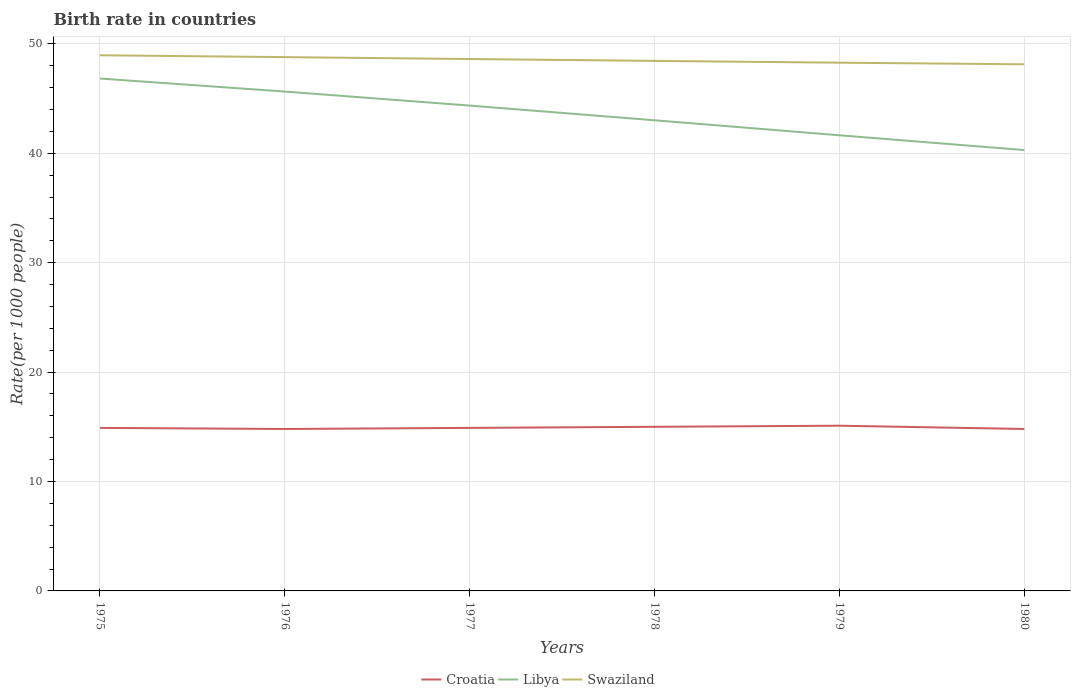How many different coloured lines are there?
Make the answer very short. 3. Does the line corresponding to Swaziland intersect with the line corresponding to Libya?
Your answer should be compact. No. Across all years, what is the maximum birth rate in Swaziland?
Provide a short and direct response. 48.13. In which year was the birth rate in Swaziland maximum?
Offer a very short reply. 1980. What is the total birth rate in Croatia in the graph?
Offer a very short reply. -0.3. What is the difference between the highest and the second highest birth rate in Croatia?
Your answer should be compact. 0.3. Is the birth rate in Croatia strictly greater than the birth rate in Swaziland over the years?
Keep it short and to the point. Yes. How many years are there in the graph?
Make the answer very short. 6. Are the values on the major ticks of Y-axis written in scientific E-notation?
Make the answer very short. No. Does the graph contain any zero values?
Provide a short and direct response. No. Does the graph contain grids?
Your answer should be compact. Yes. How are the legend labels stacked?
Your response must be concise. Horizontal. What is the title of the graph?
Ensure brevity in your answer.  Birth rate in countries. What is the label or title of the Y-axis?
Make the answer very short. Rate(per 1000 people). What is the Rate(per 1000 people) of Libya in 1975?
Keep it short and to the point. 46.83. What is the Rate(per 1000 people) in Swaziland in 1975?
Offer a terse response. 48.95. What is the Rate(per 1000 people) of Libya in 1976?
Provide a succinct answer. 45.64. What is the Rate(per 1000 people) in Swaziland in 1976?
Offer a terse response. 48.78. What is the Rate(per 1000 people) in Croatia in 1977?
Ensure brevity in your answer.  14.9. What is the Rate(per 1000 people) in Libya in 1977?
Your response must be concise. 44.36. What is the Rate(per 1000 people) in Swaziland in 1977?
Provide a short and direct response. 48.61. What is the Rate(per 1000 people) in Libya in 1978?
Provide a short and direct response. 43.01. What is the Rate(per 1000 people) in Swaziland in 1978?
Give a very brief answer. 48.44. What is the Rate(per 1000 people) in Libya in 1979?
Provide a short and direct response. 41.64. What is the Rate(per 1000 people) in Swaziland in 1979?
Ensure brevity in your answer.  48.28. What is the Rate(per 1000 people) in Libya in 1980?
Offer a terse response. 40.29. What is the Rate(per 1000 people) in Swaziland in 1980?
Ensure brevity in your answer.  48.13. Across all years, what is the maximum Rate(per 1000 people) of Croatia?
Offer a terse response. 15.1. Across all years, what is the maximum Rate(per 1000 people) of Libya?
Provide a short and direct response. 46.83. Across all years, what is the maximum Rate(per 1000 people) in Swaziland?
Make the answer very short. 48.95. Across all years, what is the minimum Rate(per 1000 people) in Libya?
Your response must be concise. 40.29. Across all years, what is the minimum Rate(per 1000 people) in Swaziland?
Your answer should be compact. 48.13. What is the total Rate(per 1000 people) of Croatia in the graph?
Your answer should be compact. 89.5. What is the total Rate(per 1000 people) of Libya in the graph?
Offer a terse response. 261.77. What is the total Rate(per 1000 people) of Swaziland in the graph?
Offer a very short reply. 291.2. What is the difference between the Rate(per 1000 people) of Libya in 1975 and that in 1976?
Your answer should be compact. 1.19. What is the difference between the Rate(per 1000 people) in Swaziland in 1975 and that in 1976?
Provide a succinct answer. 0.17. What is the difference between the Rate(per 1000 people) in Croatia in 1975 and that in 1977?
Your answer should be compact. 0. What is the difference between the Rate(per 1000 people) in Libya in 1975 and that in 1977?
Offer a very short reply. 2.47. What is the difference between the Rate(per 1000 people) of Swaziland in 1975 and that in 1977?
Make the answer very short. 0.34. What is the difference between the Rate(per 1000 people) of Croatia in 1975 and that in 1978?
Give a very brief answer. -0.1. What is the difference between the Rate(per 1000 people) in Libya in 1975 and that in 1978?
Provide a succinct answer. 3.82. What is the difference between the Rate(per 1000 people) of Swaziland in 1975 and that in 1978?
Provide a succinct answer. 0.52. What is the difference between the Rate(per 1000 people) of Croatia in 1975 and that in 1979?
Your response must be concise. -0.2. What is the difference between the Rate(per 1000 people) of Libya in 1975 and that in 1979?
Offer a very short reply. 5.19. What is the difference between the Rate(per 1000 people) of Swaziland in 1975 and that in 1979?
Give a very brief answer. 0.68. What is the difference between the Rate(per 1000 people) of Croatia in 1975 and that in 1980?
Offer a terse response. 0.1. What is the difference between the Rate(per 1000 people) in Libya in 1975 and that in 1980?
Provide a succinct answer. 6.54. What is the difference between the Rate(per 1000 people) in Swaziland in 1975 and that in 1980?
Your answer should be compact. 0.83. What is the difference between the Rate(per 1000 people) in Libya in 1976 and that in 1977?
Offer a terse response. 1.28. What is the difference between the Rate(per 1000 people) of Swaziland in 1976 and that in 1977?
Make the answer very short. 0.17. What is the difference between the Rate(per 1000 people) of Croatia in 1976 and that in 1978?
Your response must be concise. -0.2. What is the difference between the Rate(per 1000 people) of Libya in 1976 and that in 1978?
Your answer should be very brief. 2.62. What is the difference between the Rate(per 1000 people) of Swaziland in 1976 and that in 1978?
Give a very brief answer. 0.34. What is the difference between the Rate(per 1000 people) in Libya in 1976 and that in 1979?
Your answer should be compact. 4. What is the difference between the Rate(per 1000 people) in Swaziland in 1976 and that in 1979?
Keep it short and to the point. 0.51. What is the difference between the Rate(per 1000 people) in Croatia in 1976 and that in 1980?
Give a very brief answer. 0. What is the difference between the Rate(per 1000 people) in Libya in 1976 and that in 1980?
Give a very brief answer. 5.35. What is the difference between the Rate(per 1000 people) in Swaziland in 1976 and that in 1980?
Make the answer very short. 0.66. What is the difference between the Rate(per 1000 people) in Croatia in 1977 and that in 1978?
Keep it short and to the point. -0.1. What is the difference between the Rate(per 1000 people) in Libya in 1977 and that in 1978?
Provide a short and direct response. 1.34. What is the difference between the Rate(per 1000 people) in Swaziland in 1977 and that in 1978?
Your response must be concise. 0.17. What is the difference between the Rate(per 1000 people) of Libya in 1977 and that in 1979?
Provide a succinct answer. 2.71. What is the difference between the Rate(per 1000 people) in Swaziland in 1977 and that in 1979?
Your response must be concise. 0.33. What is the difference between the Rate(per 1000 people) in Libya in 1977 and that in 1980?
Your answer should be compact. 4.07. What is the difference between the Rate(per 1000 people) of Swaziland in 1977 and that in 1980?
Your response must be concise. 0.48. What is the difference between the Rate(per 1000 people) in Croatia in 1978 and that in 1979?
Make the answer very short. -0.1. What is the difference between the Rate(per 1000 people) in Libya in 1978 and that in 1979?
Your answer should be very brief. 1.37. What is the difference between the Rate(per 1000 people) of Swaziland in 1978 and that in 1979?
Offer a very short reply. 0.16. What is the difference between the Rate(per 1000 people) of Libya in 1978 and that in 1980?
Your response must be concise. 2.72. What is the difference between the Rate(per 1000 people) in Swaziland in 1978 and that in 1980?
Ensure brevity in your answer.  0.31. What is the difference between the Rate(per 1000 people) of Croatia in 1979 and that in 1980?
Your answer should be very brief. 0.3. What is the difference between the Rate(per 1000 people) of Libya in 1979 and that in 1980?
Your response must be concise. 1.35. What is the difference between the Rate(per 1000 people) of Swaziland in 1979 and that in 1980?
Provide a succinct answer. 0.15. What is the difference between the Rate(per 1000 people) in Croatia in 1975 and the Rate(per 1000 people) in Libya in 1976?
Your response must be concise. -30.74. What is the difference between the Rate(per 1000 people) in Croatia in 1975 and the Rate(per 1000 people) in Swaziland in 1976?
Offer a terse response. -33.88. What is the difference between the Rate(per 1000 people) of Libya in 1975 and the Rate(per 1000 people) of Swaziland in 1976?
Ensure brevity in your answer.  -1.96. What is the difference between the Rate(per 1000 people) in Croatia in 1975 and the Rate(per 1000 people) in Libya in 1977?
Keep it short and to the point. -29.46. What is the difference between the Rate(per 1000 people) of Croatia in 1975 and the Rate(per 1000 people) of Swaziland in 1977?
Make the answer very short. -33.71. What is the difference between the Rate(per 1000 people) in Libya in 1975 and the Rate(per 1000 people) in Swaziland in 1977?
Your response must be concise. -1.78. What is the difference between the Rate(per 1000 people) in Croatia in 1975 and the Rate(per 1000 people) in Libya in 1978?
Your answer should be very brief. -28.11. What is the difference between the Rate(per 1000 people) in Croatia in 1975 and the Rate(per 1000 people) in Swaziland in 1978?
Ensure brevity in your answer.  -33.54. What is the difference between the Rate(per 1000 people) in Libya in 1975 and the Rate(per 1000 people) in Swaziland in 1978?
Give a very brief answer. -1.61. What is the difference between the Rate(per 1000 people) in Croatia in 1975 and the Rate(per 1000 people) in Libya in 1979?
Keep it short and to the point. -26.74. What is the difference between the Rate(per 1000 people) in Croatia in 1975 and the Rate(per 1000 people) in Swaziland in 1979?
Ensure brevity in your answer.  -33.38. What is the difference between the Rate(per 1000 people) in Libya in 1975 and the Rate(per 1000 people) in Swaziland in 1979?
Give a very brief answer. -1.45. What is the difference between the Rate(per 1000 people) in Croatia in 1975 and the Rate(per 1000 people) in Libya in 1980?
Give a very brief answer. -25.39. What is the difference between the Rate(per 1000 people) of Croatia in 1975 and the Rate(per 1000 people) of Swaziland in 1980?
Ensure brevity in your answer.  -33.23. What is the difference between the Rate(per 1000 people) in Libya in 1975 and the Rate(per 1000 people) in Swaziland in 1980?
Provide a short and direct response. -1.3. What is the difference between the Rate(per 1000 people) of Croatia in 1976 and the Rate(per 1000 people) of Libya in 1977?
Give a very brief answer. -29.56. What is the difference between the Rate(per 1000 people) of Croatia in 1976 and the Rate(per 1000 people) of Swaziland in 1977?
Give a very brief answer. -33.81. What is the difference between the Rate(per 1000 people) in Libya in 1976 and the Rate(per 1000 people) in Swaziland in 1977?
Your response must be concise. -2.97. What is the difference between the Rate(per 1000 people) of Croatia in 1976 and the Rate(per 1000 people) of Libya in 1978?
Make the answer very short. -28.21. What is the difference between the Rate(per 1000 people) in Croatia in 1976 and the Rate(per 1000 people) in Swaziland in 1978?
Offer a terse response. -33.64. What is the difference between the Rate(per 1000 people) in Libya in 1976 and the Rate(per 1000 people) in Swaziland in 1978?
Offer a very short reply. -2.8. What is the difference between the Rate(per 1000 people) in Croatia in 1976 and the Rate(per 1000 people) in Libya in 1979?
Give a very brief answer. -26.84. What is the difference between the Rate(per 1000 people) in Croatia in 1976 and the Rate(per 1000 people) in Swaziland in 1979?
Your answer should be very brief. -33.48. What is the difference between the Rate(per 1000 people) of Libya in 1976 and the Rate(per 1000 people) of Swaziland in 1979?
Your answer should be very brief. -2.64. What is the difference between the Rate(per 1000 people) in Croatia in 1976 and the Rate(per 1000 people) in Libya in 1980?
Offer a terse response. -25.49. What is the difference between the Rate(per 1000 people) of Croatia in 1976 and the Rate(per 1000 people) of Swaziland in 1980?
Offer a very short reply. -33.33. What is the difference between the Rate(per 1000 people) in Libya in 1976 and the Rate(per 1000 people) in Swaziland in 1980?
Offer a terse response. -2.49. What is the difference between the Rate(per 1000 people) of Croatia in 1977 and the Rate(per 1000 people) of Libya in 1978?
Offer a very short reply. -28.11. What is the difference between the Rate(per 1000 people) of Croatia in 1977 and the Rate(per 1000 people) of Swaziland in 1978?
Provide a short and direct response. -33.54. What is the difference between the Rate(per 1000 people) in Libya in 1977 and the Rate(per 1000 people) in Swaziland in 1978?
Ensure brevity in your answer.  -4.08. What is the difference between the Rate(per 1000 people) of Croatia in 1977 and the Rate(per 1000 people) of Libya in 1979?
Your answer should be very brief. -26.74. What is the difference between the Rate(per 1000 people) of Croatia in 1977 and the Rate(per 1000 people) of Swaziland in 1979?
Give a very brief answer. -33.38. What is the difference between the Rate(per 1000 people) of Libya in 1977 and the Rate(per 1000 people) of Swaziland in 1979?
Your response must be concise. -3.92. What is the difference between the Rate(per 1000 people) of Croatia in 1977 and the Rate(per 1000 people) of Libya in 1980?
Provide a short and direct response. -25.39. What is the difference between the Rate(per 1000 people) in Croatia in 1977 and the Rate(per 1000 people) in Swaziland in 1980?
Your answer should be compact. -33.23. What is the difference between the Rate(per 1000 people) of Libya in 1977 and the Rate(per 1000 people) of Swaziland in 1980?
Provide a succinct answer. -3.77. What is the difference between the Rate(per 1000 people) in Croatia in 1978 and the Rate(per 1000 people) in Libya in 1979?
Provide a short and direct response. -26.64. What is the difference between the Rate(per 1000 people) of Croatia in 1978 and the Rate(per 1000 people) of Swaziland in 1979?
Provide a succinct answer. -33.28. What is the difference between the Rate(per 1000 people) of Libya in 1978 and the Rate(per 1000 people) of Swaziland in 1979?
Your answer should be compact. -5.26. What is the difference between the Rate(per 1000 people) in Croatia in 1978 and the Rate(per 1000 people) in Libya in 1980?
Make the answer very short. -25.29. What is the difference between the Rate(per 1000 people) of Croatia in 1978 and the Rate(per 1000 people) of Swaziland in 1980?
Your answer should be compact. -33.13. What is the difference between the Rate(per 1000 people) in Libya in 1978 and the Rate(per 1000 people) in Swaziland in 1980?
Make the answer very short. -5.12. What is the difference between the Rate(per 1000 people) in Croatia in 1979 and the Rate(per 1000 people) in Libya in 1980?
Offer a terse response. -25.19. What is the difference between the Rate(per 1000 people) of Croatia in 1979 and the Rate(per 1000 people) of Swaziland in 1980?
Provide a short and direct response. -33.03. What is the difference between the Rate(per 1000 people) in Libya in 1979 and the Rate(per 1000 people) in Swaziland in 1980?
Your answer should be compact. -6.49. What is the average Rate(per 1000 people) of Croatia per year?
Provide a short and direct response. 14.92. What is the average Rate(per 1000 people) of Libya per year?
Provide a succinct answer. 43.63. What is the average Rate(per 1000 people) of Swaziland per year?
Offer a very short reply. 48.53. In the year 1975, what is the difference between the Rate(per 1000 people) of Croatia and Rate(per 1000 people) of Libya?
Your answer should be compact. -31.93. In the year 1975, what is the difference between the Rate(per 1000 people) of Croatia and Rate(per 1000 people) of Swaziland?
Make the answer very short. -34.05. In the year 1975, what is the difference between the Rate(per 1000 people) of Libya and Rate(per 1000 people) of Swaziland?
Your answer should be compact. -2.12. In the year 1976, what is the difference between the Rate(per 1000 people) in Croatia and Rate(per 1000 people) in Libya?
Provide a succinct answer. -30.84. In the year 1976, what is the difference between the Rate(per 1000 people) of Croatia and Rate(per 1000 people) of Swaziland?
Your response must be concise. -33.98. In the year 1976, what is the difference between the Rate(per 1000 people) of Libya and Rate(per 1000 people) of Swaziland?
Provide a short and direct response. -3.15. In the year 1977, what is the difference between the Rate(per 1000 people) of Croatia and Rate(per 1000 people) of Libya?
Provide a short and direct response. -29.46. In the year 1977, what is the difference between the Rate(per 1000 people) in Croatia and Rate(per 1000 people) in Swaziland?
Keep it short and to the point. -33.71. In the year 1977, what is the difference between the Rate(per 1000 people) in Libya and Rate(per 1000 people) in Swaziland?
Your answer should be compact. -4.25. In the year 1978, what is the difference between the Rate(per 1000 people) in Croatia and Rate(per 1000 people) in Libya?
Make the answer very short. -28.01. In the year 1978, what is the difference between the Rate(per 1000 people) in Croatia and Rate(per 1000 people) in Swaziland?
Give a very brief answer. -33.44. In the year 1978, what is the difference between the Rate(per 1000 people) in Libya and Rate(per 1000 people) in Swaziland?
Make the answer very short. -5.43. In the year 1979, what is the difference between the Rate(per 1000 people) of Croatia and Rate(per 1000 people) of Libya?
Provide a short and direct response. -26.54. In the year 1979, what is the difference between the Rate(per 1000 people) of Croatia and Rate(per 1000 people) of Swaziland?
Ensure brevity in your answer.  -33.18. In the year 1979, what is the difference between the Rate(per 1000 people) in Libya and Rate(per 1000 people) in Swaziland?
Make the answer very short. -6.63. In the year 1980, what is the difference between the Rate(per 1000 people) of Croatia and Rate(per 1000 people) of Libya?
Keep it short and to the point. -25.49. In the year 1980, what is the difference between the Rate(per 1000 people) in Croatia and Rate(per 1000 people) in Swaziland?
Give a very brief answer. -33.33. In the year 1980, what is the difference between the Rate(per 1000 people) in Libya and Rate(per 1000 people) in Swaziland?
Keep it short and to the point. -7.84. What is the ratio of the Rate(per 1000 people) of Croatia in 1975 to that in 1976?
Offer a very short reply. 1.01. What is the ratio of the Rate(per 1000 people) of Libya in 1975 to that in 1976?
Make the answer very short. 1.03. What is the ratio of the Rate(per 1000 people) of Swaziland in 1975 to that in 1976?
Your answer should be compact. 1. What is the ratio of the Rate(per 1000 people) of Croatia in 1975 to that in 1977?
Offer a terse response. 1. What is the ratio of the Rate(per 1000 people) in Libya in 1975 to that in 1977?
Your answer should be very brief. 1.06. What is the ratio of the Rate(per 1000 people) of Swaziland in 1975 to that in 1977?
Offer a very short reply. 1.01. What is the ratio of the Rate(per 1000 people) of Libya in 1975 to that in 1978?
Offer a terse response. 1.09. What is the ratio of the Rate(per 1000 people) in Swaziland in 1975 to that in 1978?
Ensure brevity in your answer.  1.01. What is the ratio of the Rate(per 1000 people) in Croatia in 1975 to that in 1979?
Provide a succinct answer. 0.99. What is the ratio of the Rate(per 1000 people) of Libya in 1975 to that in 1979?
Make the answer very short. 1.12. What is the ratio of the Rate(per 1000 people) in Croatia in 1975 to that in 1980?
Your answer should be compact. 1.01. What is the ratio of the Rate(per 1000 people) of Libya in 1975 to that in 1980?
Your response must be concise. 1.16. What is the ratio of the Rate(per 1000 people) of Swaziland in 1975 to that in 1980?
Keep it short and to the point. 1.02. What is the ratio of the Rate(per 1000 people) in Libya in 1976 to that in 1977?
Ensure brevity in your answer.  1.03. What is the ratio of the Rate(per 1000 people) in Croatia in 1976 to that in 1978?
Provide a succinct answer. 0.99. What is the ratio of the Rate(per 1000 people) in Libya in 1976 to that in 1978?
Give a very brief answer. 1.06. What is the ratio of the Rate(per 1000 people) in Swaziland in 1976 to that in 1978?
Your answer should be very brief. 1.01. What is the ratio of the Rate(per 1000 people) in Croatia in 1976 to that in 1979?
Provide a short and direct response. 0.98. What is the ratio of the Rate(per 1000 people) of Libya in 1976 to that in 1979?
Give a very brief answer. 1.1. What is the ratio of the Rate(per 1000 people) in Swaziland in 1976 to that in 1979?
Offer a very short reply. 1.01. What is the ratio of the Rate(per 1000 people) in Libya in 1976 to that in 1980?
Ensure brevity in your answer.  1.13. What is the ratio of the Rate(per 1000 people) in Swaziland in 1976 to that in 1980?
Provide a succinct answer. 1.01. What is the ratio of the Rate(per 1000 people) in Libya in 1977 to that in 1978?
Keep it short and to the point. 1.03. What is the ratio of the Rate(per 1000 people) of Swaziland in 1977 to that in 1978?
Keep it short and to the point. 1. What is the ratio of the Rate(per 1000 people) of Croatia in 1977 to that in 1979?
Keep it short and to the point. 0.99. What is the ratio of the Rate(per 1000 people) of Libya in 1977 to that in 1979?
Your response must be concise. 1.07. What is the ratio of the Rate(per 1000 people) of Croatia in 1977 to that in 1980?
Offer a very short reply. 1.01. What is the ratio of the Rate(per 1000 people) of Libya in 1977 to that in 1980?
Give a very brief answer. 1.1. What is the ratio of the Rate(per 1000 people) in Libya in 1978 to that in 1979?
Ensure brevity in your answer.  1.03. What is the ratio of the Rate(per 1000 people) of Croatia in 1978 to that in 1980?
Offer a terse response. 1.01. What is the ratio of the Rate(per 1000 people) in Libya in 1978 to that in 1980?
Give a very brief answer. 1.07. What is the ratio of the Rate(per 1000 people) of Croatia in 1979 to that in 1980?
Your answer should be very brief. 1.02. What is the ratio of the Rate(per 1000 people) in Libya in 1979 to that in 1980?
Give a very brief answer. 1.03. What is the difference between the highest and the second highest Rate(per 1000 people) in Libya?
Make the answer very short. 1.19. What is the difference between the highest and the second highest Rate(per 1000 people) of Swaziland?
Offer a very short reply. 0.17. What is the difference between the highest and the lowest Rate(per 1000 people) in Libya?
Ensure brevity in your answer.  6.54. What is the difference between the highest and the lowest Rate(per 1000 people) in Swaziland?
Your answer should be very brief. 0.83. 